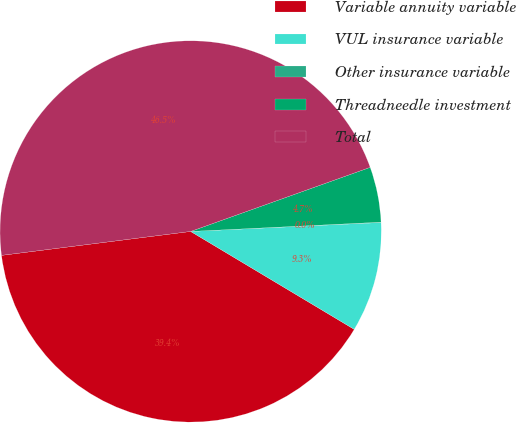Convert chart to OTSL. <chart><loc_0><loc_0><loc_500><loc_500><pie_chart><fcel>Variable annuity variable<fcel>VUL insurance variable<fcel>Other insurance variable<fcel>Threadneedle investment<fcel>Total<nl><fcel>39.41%<fcel>9.33%<fcel>0.03%<fcel>4.68%<fcel>46.54%<nl></chart> 